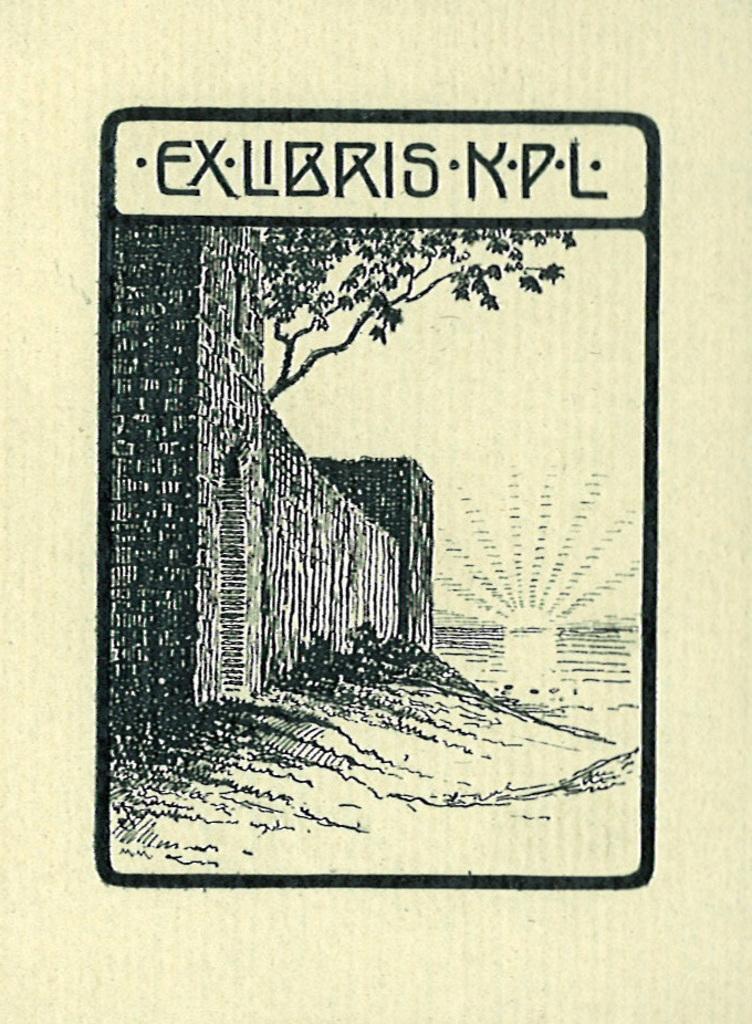Please provide a concise description of this image. In this image we can see a poster where we can see a wall, a tree and a text. 